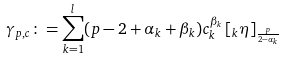<formula> <loc_0><loc_0><loc_500><loc_500>\gamma _ { p , c } \colon = \sum _ { k = 1 } ^ { l } ( p - 2 + \alpha _ { k } + \beta _ { k } ) c _ { k } ^ { \beta _ { k } } \left [ \null _ { k } \eta \right ] _ { \frac { p } { 2 - \alpha _ { k } } }</formula> 